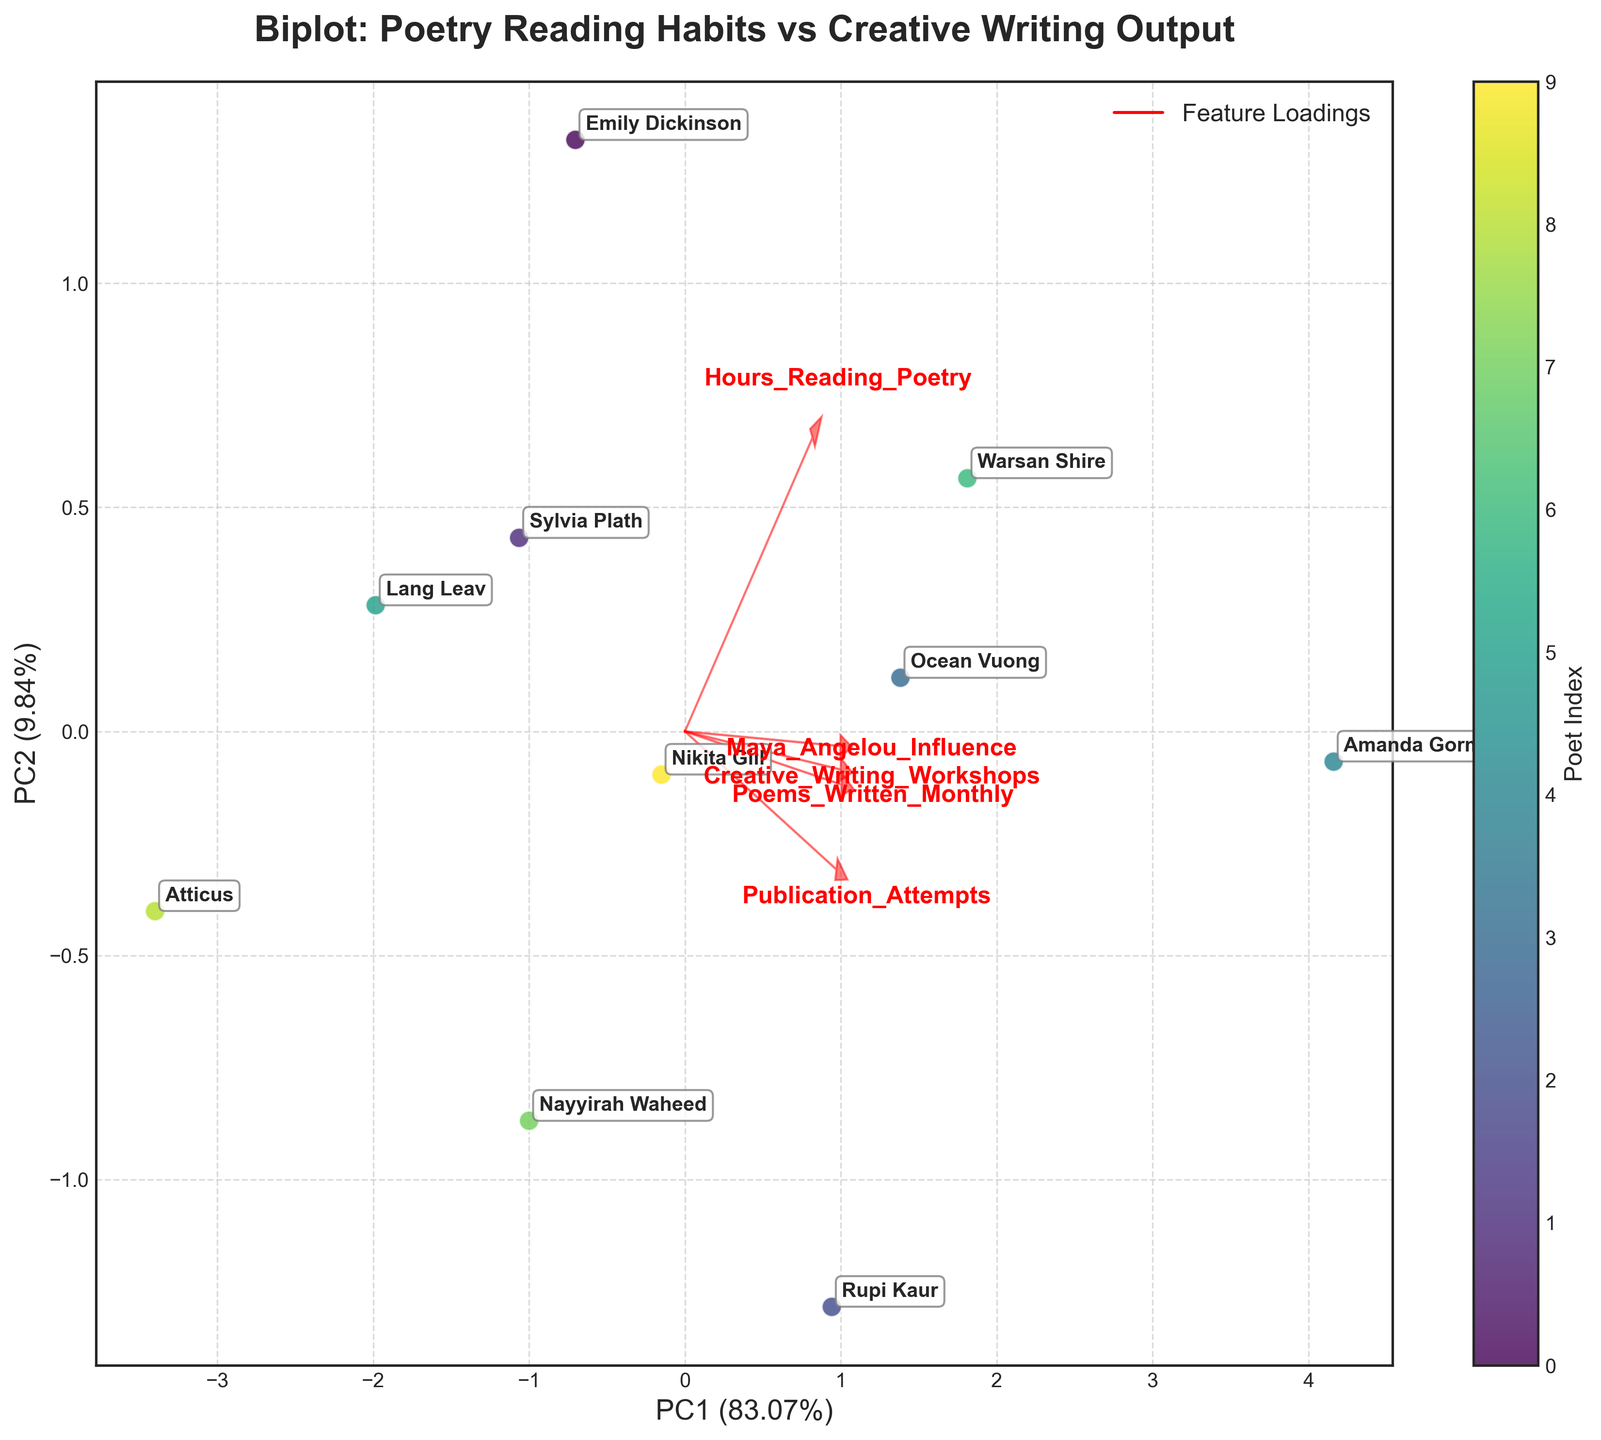What is the title of the figure? The title of the figure is displayed at the top. It reads "Biplot: Poetry Reading Habits vs Creative Writing Output."
Answer: Biplot: Poetry Reading Habits vs Creative Writing Output What do the x-axis and y-axis represent in the biplot? The x-axis is labeled "PC1" and the y-axis is labeled "PC2," which stand for the first and second principal components, respectively. These components represent the main directions of data variance.
Answer: PC1 and PC2 How many poets are represented in the biplot? Each data point in the scatter plot represents a poet, and the plot includes annotations for each poet's name. By counting the names, we see 10 poets are represented.
Answer: 10 Which feature has the largest influence along the PC1 axis? By examining the arrows and their corresponding lengths along the PC1 axis, we can see that the "Hours_Reading_Poetry" feature has the largest loading in this direction.
Answer: Hours_Reading_Poetry How is Maya Angelou's influence represented in the biplot? Maya Angelou's influence is represented as one of the feature vectors (red arrows). The length and direction of the arrow for this feature indicate its contribution to the principal components.
Answer: As a feature vector Which poet has the highest "Poems_Written_Monthly" value? By looking at the data points and annotations, Amanda Gorman is positioned furthest in the positive PC1 direction, where "Poems_Written_Monthly" is a key feature.
Answer: Amanda Gorman Does "Publication Attempts" have a stronger influence on PC1 or PC2? The length and direction of the "Publication_Attempts" arrow should be compared along both axes. It appears longer in the PC1 direction, indicating a stronger influence on PC1.
Answer: PC1 Which poet is positioned closest to the origin? By observing the data points and their annotations, Atticus is located nearest to the origin, where both the PC1 and PC2 values are close to zero.
Answer: Atticus Which features are positively correlated in this biplot? Positively correlated features have arrows pointing in similar directions. From the plot, "Hours_Reading_Poetry" and "Poems_Written_Monthly" have arrows pointing in somewhat similar directions, indicating positive correlation.
Answer: Hours_Reading_Poetry and Poems_Written_Monthly Is "Creative Writing Workshops" more strongly associated with PC1 or PC2? The length and orientation of the "Creative_Writing_Workshops" arrow can be checked along the PC1 and PC2 axes. It appears to be more oriented along PC2, indicating a stronger association with PC2.
Answer: PC2 